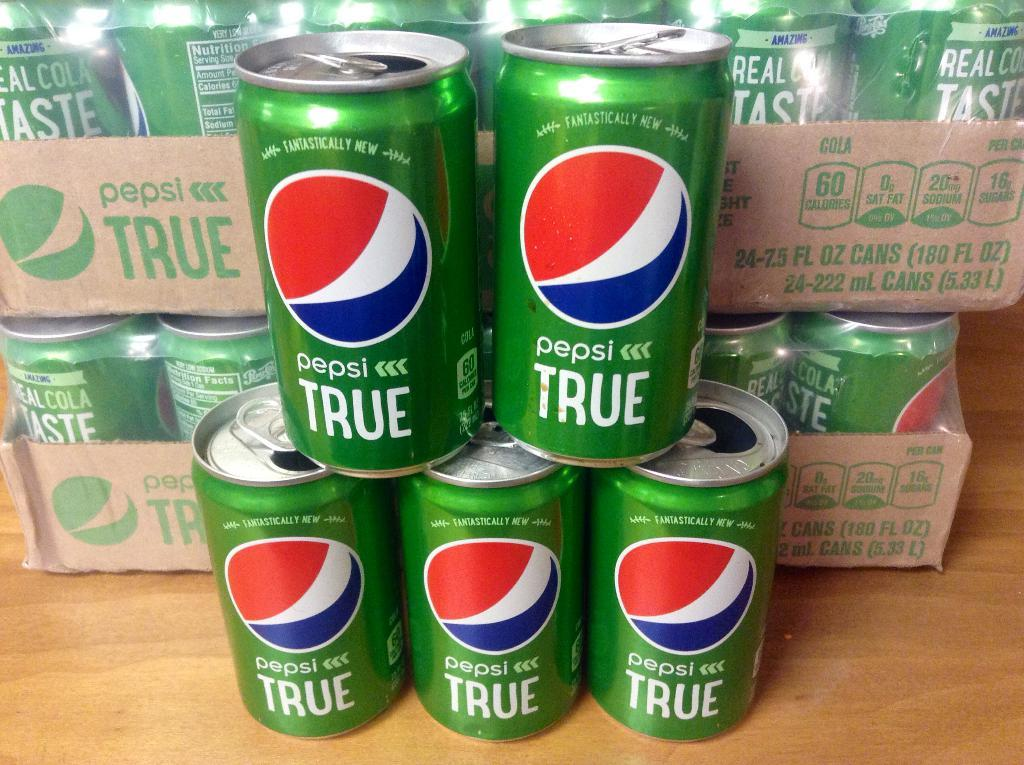<image>
Share a concise interpretation of the image provided. A stack of red, blue, white and green pepsi true cans on top of each other. 